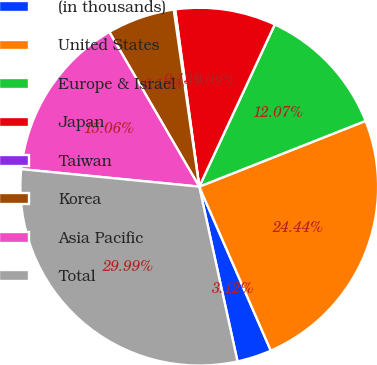Convert chart. <chart><loc_0><loc_0><loc_500><loc_500><pie_chart><fcel>(in thousands)<fcel>United States<fcel>Europe & Israel<fcel>Japan<fcel>Taiwan<fcel>Korea<fcel>Asia Pacific<fcel>Total<nl><fcel>3.12%<fcel>24.44%<fcel>12.07%<fcel>9.09%<fcel>0.13%<fcel>6.1%<fcel>15.06%<fcel>29.99%<nl></chart> 